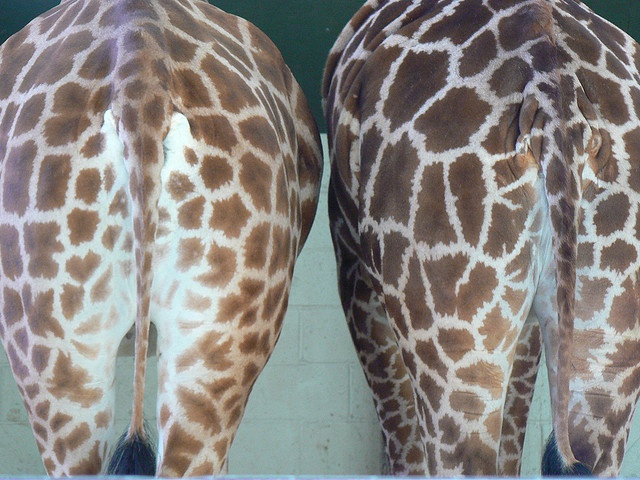Describe the objects in this image and their specific colors. I can see giraffe in teal, darkgray, lightgray, and gray tones and giraffe in teal, gray, darkgray, lightgray, and black tones in this image. 